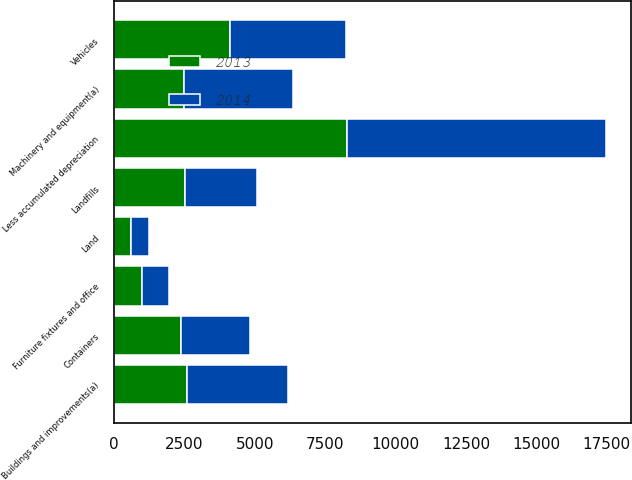Convert chart. <chart><loc_0><loc_0><loc_500><loc_500><stacked_bar_chart><ecel><fcel>Land<fcel>Landfills<fcel>Vehicles<fcel>Machinery and equipment(a)<fcel>Containers<fcel>Buildings and improvements(a)<fcel>Furniture fixtures and office<fcel>Less accumulated depreciation<nl><fcel>2013<fcel>611<fcel>2529<fcel>4131<fcel>2470<fcel>2377<fcel>2588<fcel>985<fcel>8278<nl><fcel>2014<fcel>636<fcel>2529<fcel>4115<fcel>3888<fcel>2449<fcel>3594<fcel>969<fcel>9205<nl></chart> 